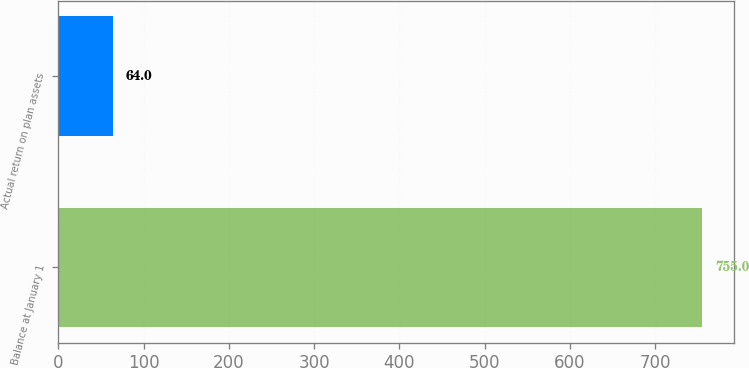Convert chart. <chart><loc_0><loc_0><loc_500><loc_500><bar_chart><fcel>Balance at January 1<fcel>Actual return on plan assets<nl><fcel>755<fcel>64<nl></chart> 